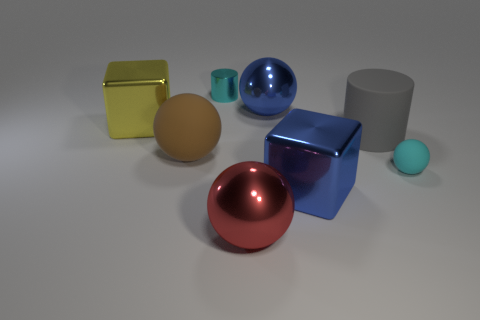Add 1 brown rubber things. How many objects exist? 9 Subtract all cubes. How many objects are left? 6 Subtract all big cubes. Subtract all big red metallic spheres. How many objects are left? 5 Add 1 small cyan metallic objects. How many small cyan metallic objects are left? 2 Add 2 red cylinders. How many red cylinders exist? 2 Subtract 1 blue cubes. How many objects are left? 7 